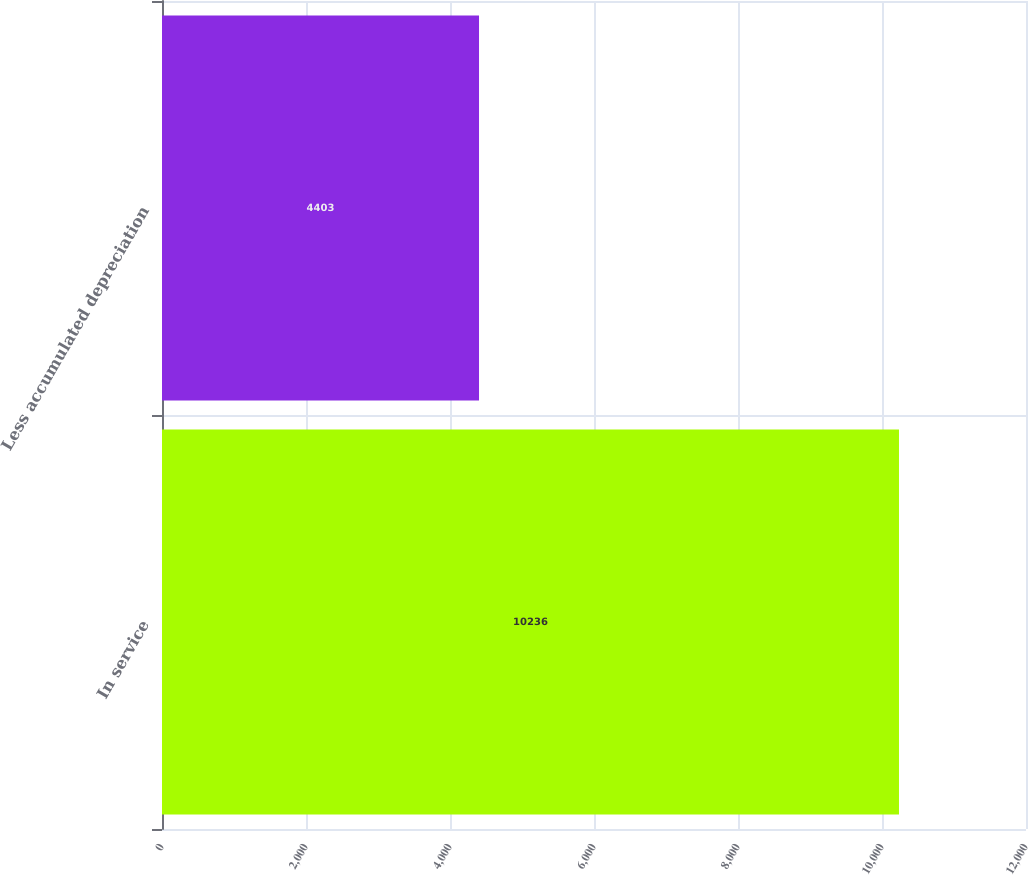Convert chart. <chart><loc_0><loc_0><loc_500><loc_500><bar_chart><fcel>In service<fcel>Less accumulated depreciation<nl><fcel>10236<fcel>4403<nl></chart> 